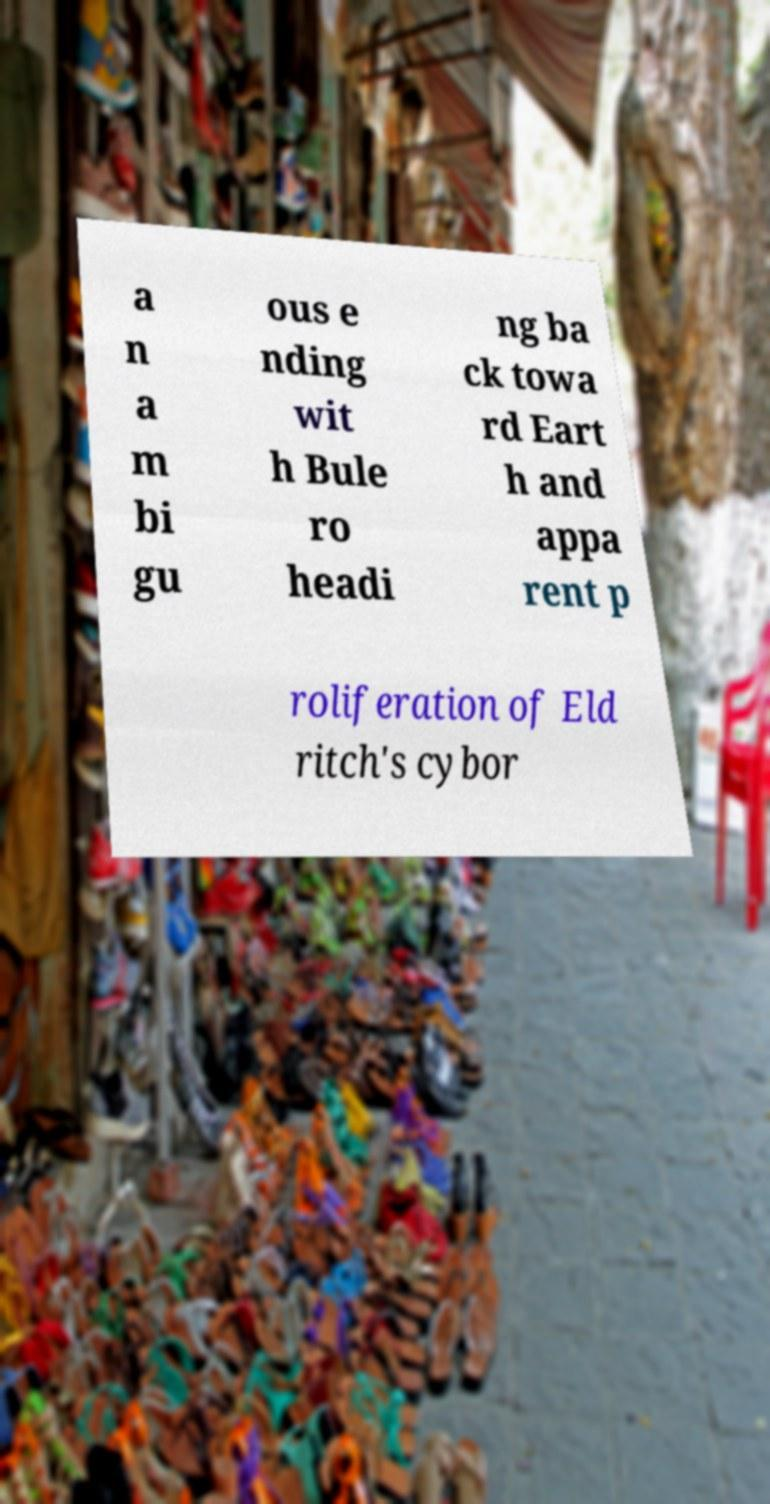For documentation purposes, I need the text within this image transcribed. Could you provide that? a n a m bi gu ous e nding wit h Bule ro headi ng ba ck towa rd Eart h and appa rent p roliferation of Eld ritch's cybor 